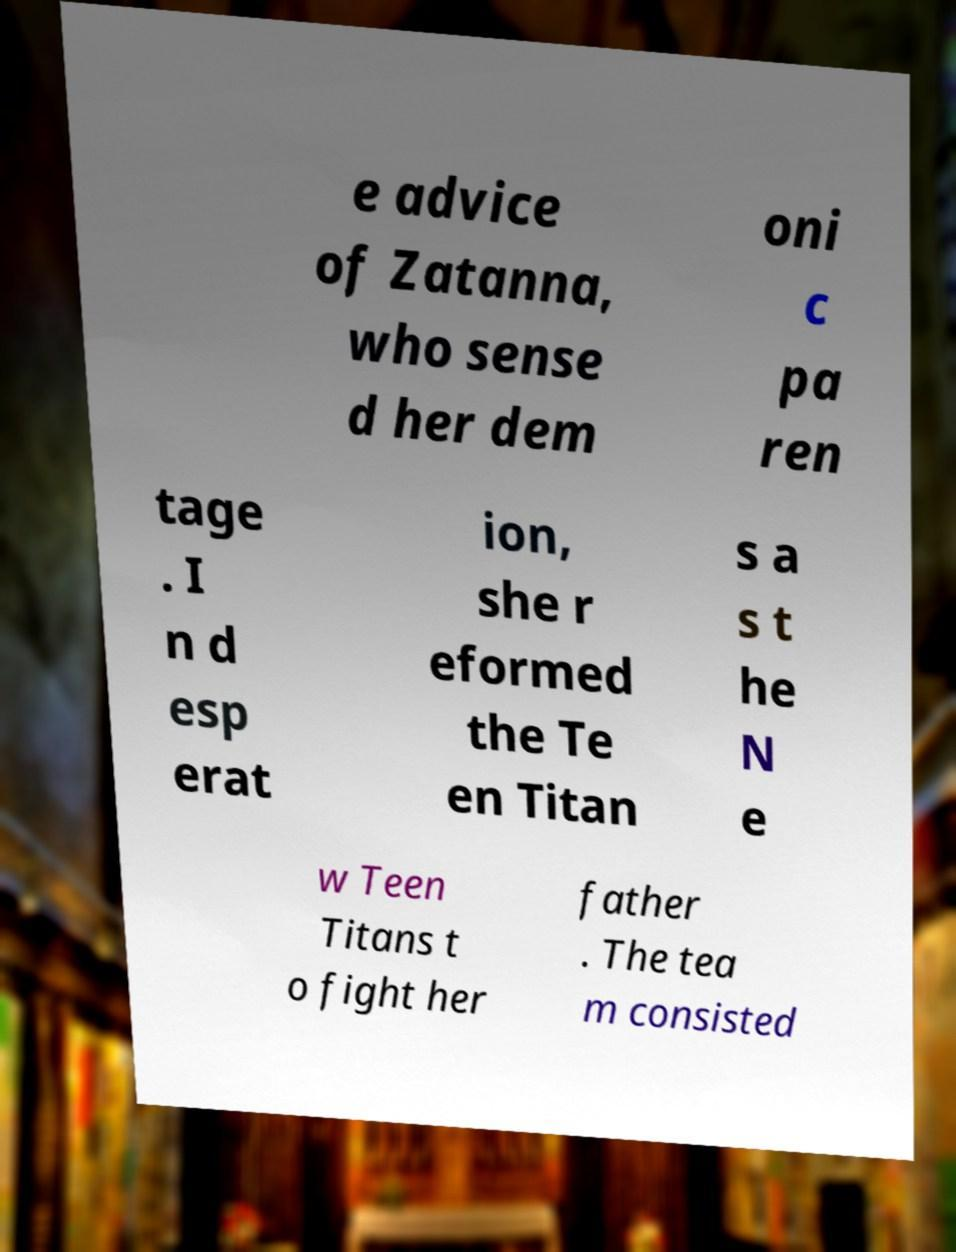I need the written content from this picture converted into text. Can you do that? e advice of Zatanna, who sense d her dem oni c pa ren tage . I n d esp erat ion, she r eformed the Te en Titan s a s t he N e w Teen Titans t o fight her father . The tea m consisted 